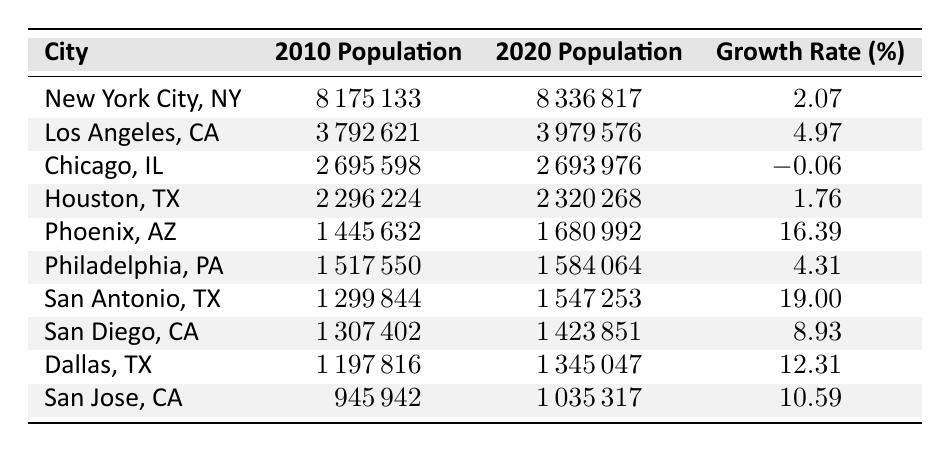What was the population of Chicago in 2020? The table indicates the population of Chicago in 2020 is listed under the "2020 Population" column, which shows 2,693,976.
Answer: 2,693,976 Which city saw the highest population growth rate from 2010 to 2020? By inspecting the "Growth Rate (%)" column, we find that San Antonio has the highest growth rate at 19.00%.
Answer: San Antonio What is the total population of New York City and Los Angeles in 2020? We need to add the populations for New York City (8,336,817) and Los Angeles (3,979,576) from the 2020 Population column: 8,336,817 + 3,979,576 = 12,316,393.
Answer: 12,316,393 Did any city experience a decrease in population from 2010 to 2020? Looking at the "Growth Rate (%)" column, Chicago is the only city with a negative growth rate of -0.06%, indicating a decline in population.
Answer: Yes What is the average growth rate of all cities listed? We calculate the average growth rate by summing all growth rates (2.07 + 4.97 - 0.06 + 1.76 + 16.39 + 4.31 + 19.00 + 8.93 + 12.31 + 10.59 = 79.28) and dividing by the number of cities (10). So, 79.28 / 10 = 7.928.
Answer: 7.93 Which city had a population of over 3 million in 2020? From the "2020 Population" column, the cities with populations over 3 million are New York City (8,336,817) and Los Angeles (3,979,576).
Answer: New York City, Los Angeles What was the population of San Diego in 2010? The table shows the population of San Diego in 2010 under the "2010 Population" column, which is 1,307,402.
Answer: 1,307,402 Which two cities have a population growth rate greater than 10%? Checking the "Growth Rate (%)" column, we find that Phoenix (16.39%) and San Antonio (19.00%) are the only cities with growth rates over 10%.
Answer: Phoenix, San Antonio 